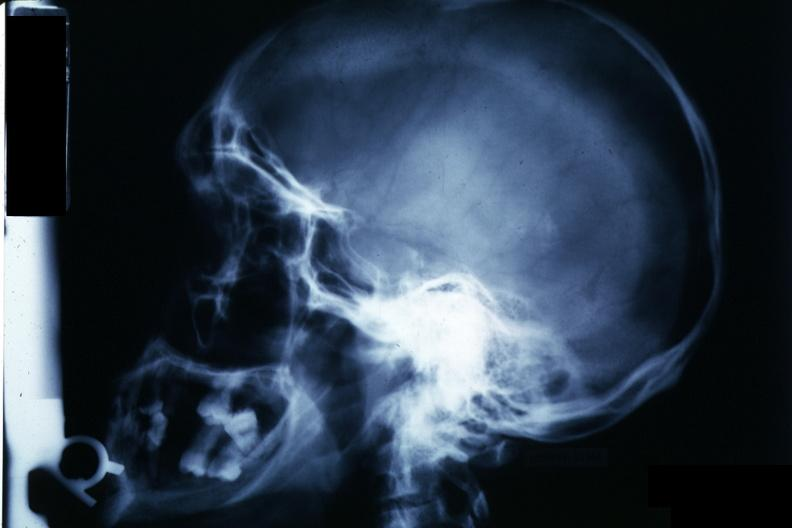does this image show x-ray sella?
Answer the question using a single word or phrase. Yes 